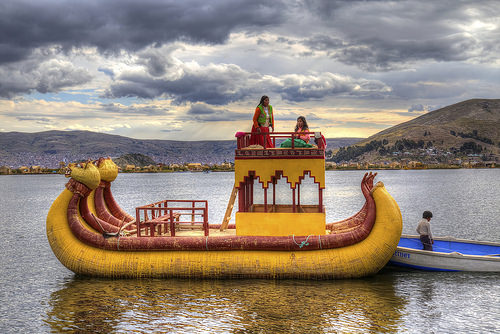<image>
Can you confirm if the boat is in front of the boy? No. The boat is not in front of the boy. The spatial positioning shows a different relationship between these objects. 